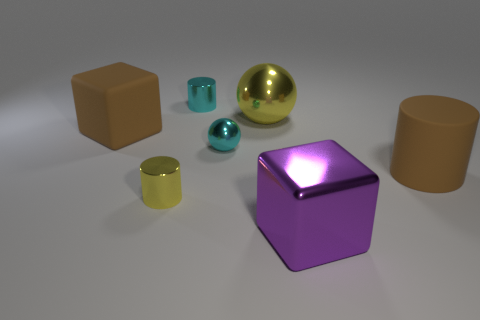Subtract all metallic cylinders. How many cylinders are left? 1 Subtract 1 blocks. How many blocks are left? 1 Add 1 rubber blocks. How many objects exist? 8 Subtract all brown blocks. How many blocks are left? 1 Subtract 0 purple cylinders. How many objects are left? 7 Subtract all cylinders. How many objects are left? 4 Subtract all blue cubes. Subtract all cyan balls. How many cubes are left? 2 Subtract all green cubes. How many blue spheres are left? 0 Subtract all cyan cylinders. Subtract all yellow cylinders. How many objects are left? 5 Add 2 big brown rubber things. How many big brown rubber things are left? 4 